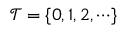Convert formula to latex. <formula><loc_0><loc_0><loc_500><loc_500>\mathcal { T } = \{ 0 , 1 , 2 , \cdots \}</formula> 